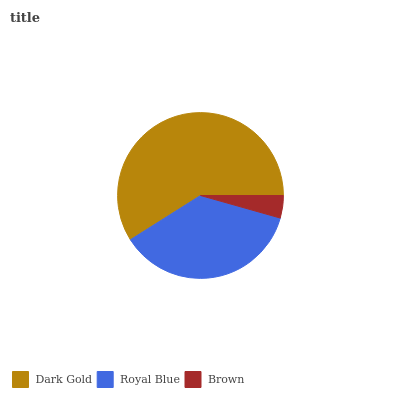Is Brown the minimum?
Answer yes or no. Yes. Is Dark Gold the maximum?
Answer yes or no. Yes. Is Royal Blue the minimum?
Answer yes or no. No. Is Royal Blue the maximum?
Answer yes or no. No. Is Dark Gold greater than Royal Blue?
Answer yes or no. Yes. Is Royal Blue less than Dark Gold?
Answer yes or no. Yes. Is Royal Blue greater than Dark Gold?
Answer yes or no. No. Is Dark Gold less than Royal Blue?
Answer yes or no. No. Is Royal Blue the high median?
Answer yes or no. Yes. Is Royal Blue the low median?
Answer yes or no. Yes. Is Dark Gold the high median?
Answer yes or no. No. Is Brown the low median?
Answer yes or no. No. 